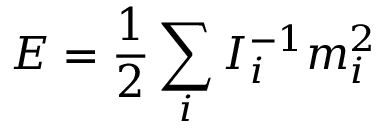Convert formula to latex. <formula><loc_0><loc_0><loc_500><loc_500>E = \frac { 1 } { 2 } \sum _ { i } I _ { i } ^ { - 1 } m _ { i } ^ { 2 }</formula> 